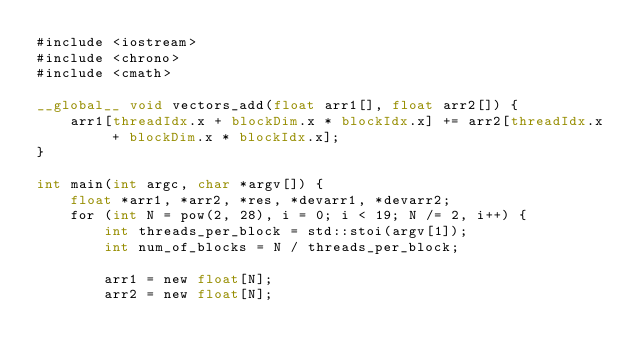<code> <loc_0><loc_0><loc_500><loc_500><_Cuda_>#include <iostream>
#include <chrono>
#include <cmath>

__global__ void vectors_add(float arr1[], float arr2[]) {
    arr1[threadIdx.x + blockDim.x * blockIdx.x] += arr2[threadIdx.x + blockDim.x * blockIdx.x];
}

int main(int argc, char *argv[]) {
    float *arr1, *arr2, *res, *devarr1, *devarr2;
    for (int N = pow(2, 28), i = 0; i < 19; N /= 2, i++) {
        int threads_per_block = std::stoi(argv[1]);
        int num_of_blocks = N / threads_per_block;

        arr1 = new float[N];
        arr2 = new float[N];</code> 